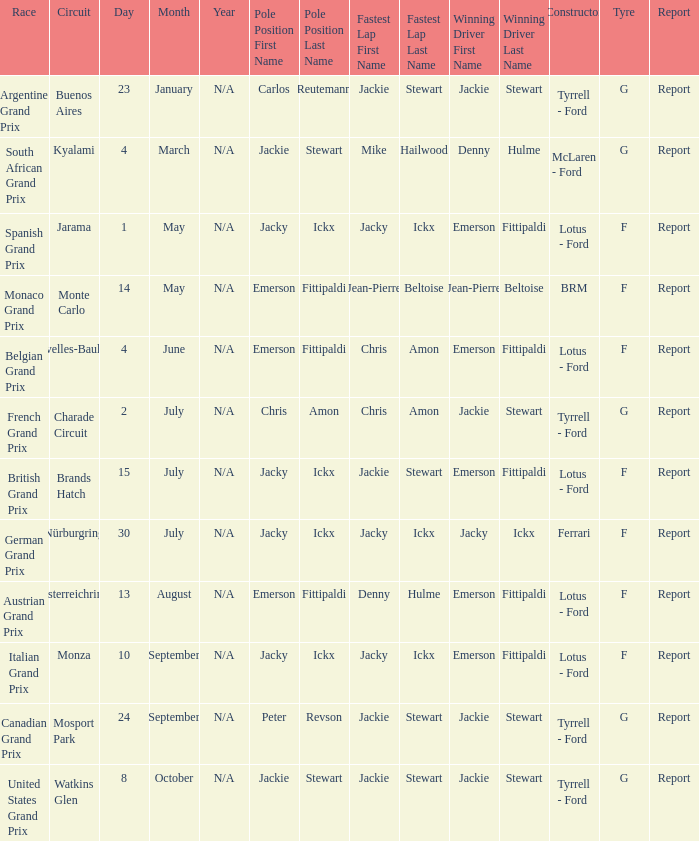What day did Emerson Fittipaldi win the Spanish Grand Prix? 1 May. 